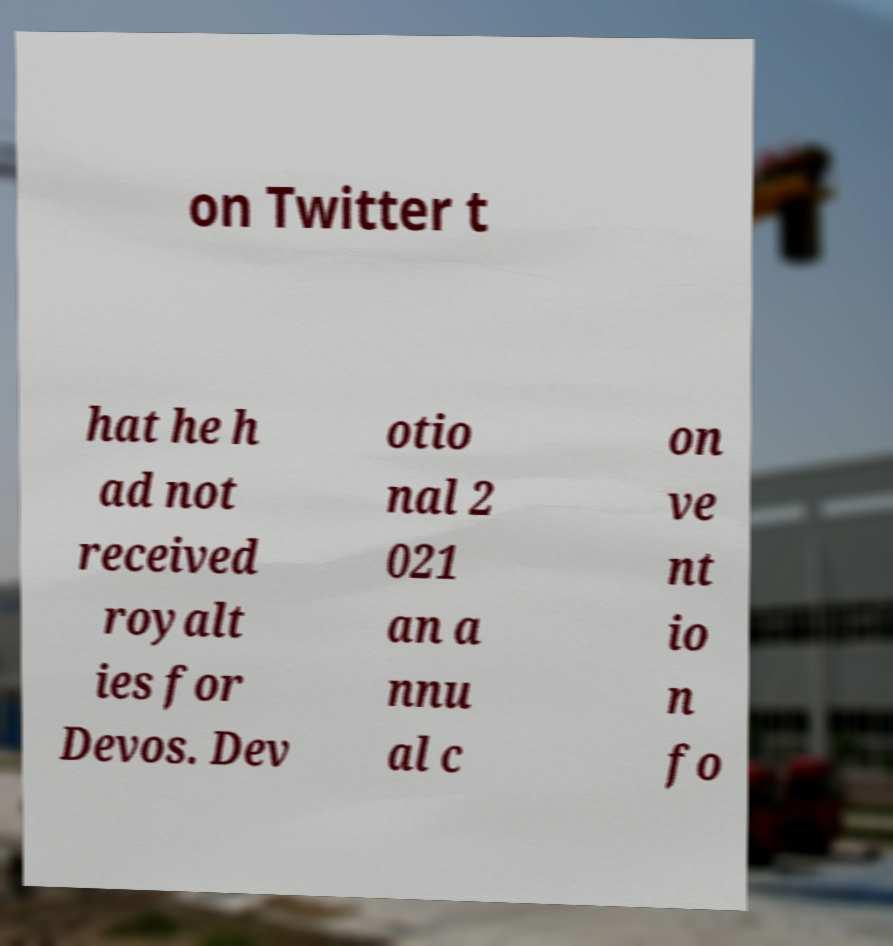There's text embedded in this image that I need extracted. Can you transcribe it verbatim? on Twitter t hat he h ad not received royalt ies for Devos. Dev otio nal 2 021 an a nnu al c on ve nt io n fo 